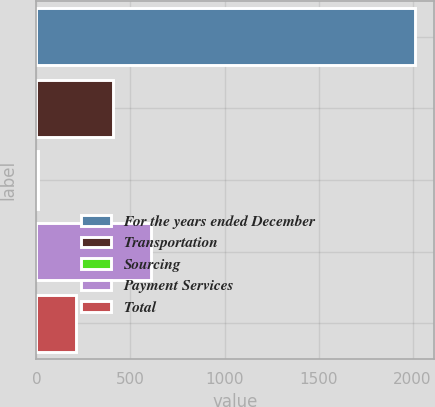<chart> <loc_0><loc_0><loc_500><loc_500><bar_chart><fcel>For the years ended December<fcel>Transportation<fcel>Sourcing<fcel>Payment Services<fcel>Total<nl><fcel>2011<fcel>408.92<fcel>8.4<fcel>609.18<fcel>208.66<nl></chart> 